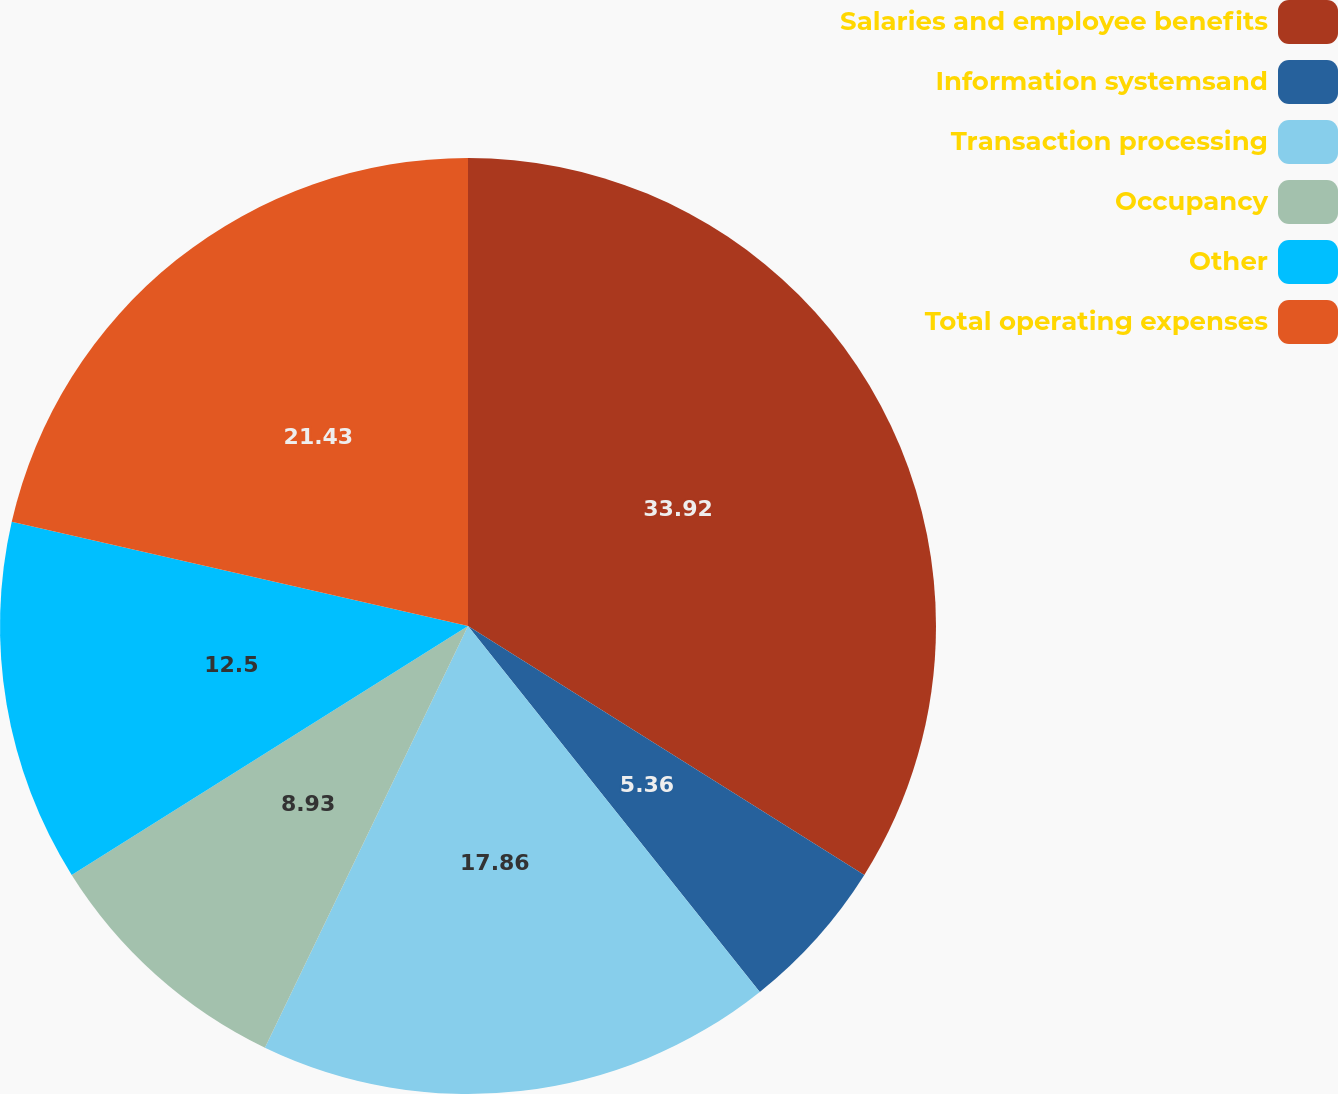Convert chart to OTSL. <chart><loc_0><loc_0><loc_500><loc_500><pie_chart><fcel>Salaries and employee benefits<fcel>Information systemsand<fcel>Transaction processing<fcel>Occupancy<fcel>Other<fcel>Total operating expenses<nl><fcel>33.93%<fcel>5.36%<fcel>17.86%<fcel>8.93%<fcel>12.5%<fcel>21.43%<nl></chart> 